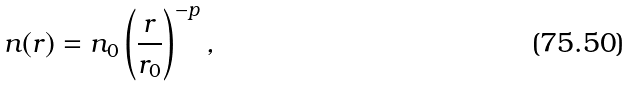Convert formula to latex. <formula><loc_0><loc_0><loc_500><loc_500>n ( r ) = n _ { 0 } \left ( \frac { r } { r _ { 0 } } \right ) ^ { - p } ,</formula> 